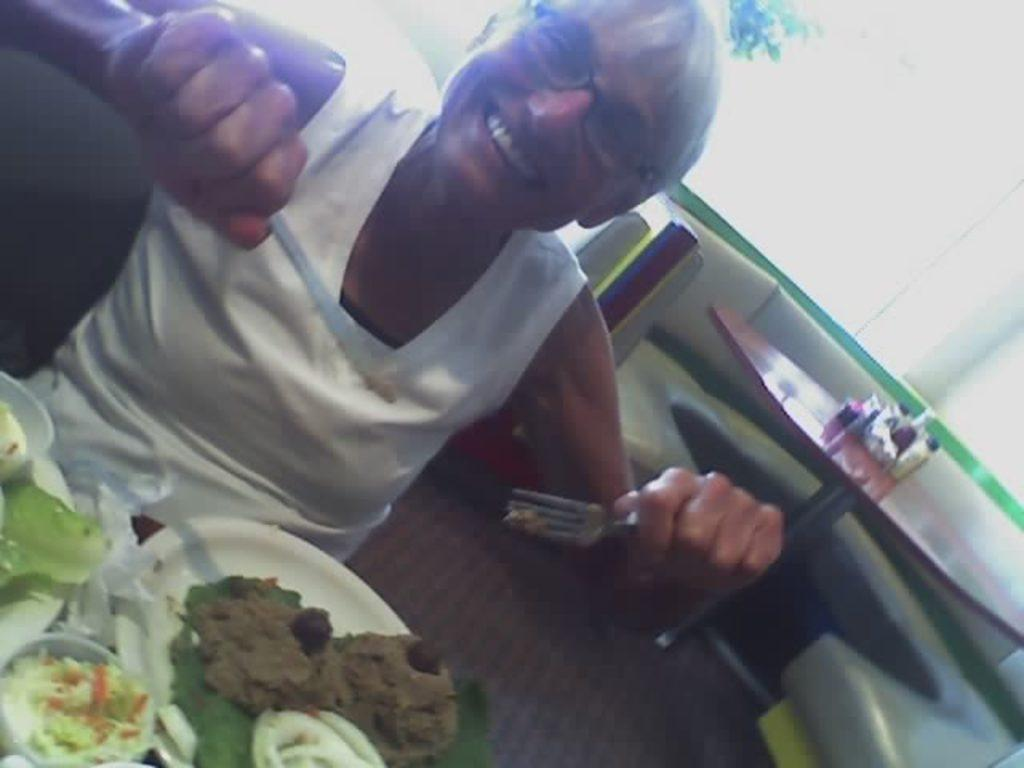What is the person in the image doing? The person is sitting in the image. What is the person holding in their left hand? The person is holding a fork in their left hand. What is the person holding in their right hand? The person is holding a knife in their right hand. What can be found on the table in the image? There are food items on the table. What type of partner is sitting next to the person in the image? There is no mention of a partner in the image. --- Facts: 1. There is a person sitting in the image. 2. The person is wearing a blue shirt. 3. The person is holding a book in their right hand. 4. The book is titled "The History of...". 5. The background of the image is a park. Absurd Topics: elephant, piano, ocean Conversation: What is the main subject in the image? The main subject in the image is a person sitting. What is the person wearing in the image? The person is wearing a blue shirt. What is the person holding in their right hand in the image? The person is holding a book in their right hand. What is the title of the book the person is holding in the image? The book is titled "The History of...". What can be seen in the background of the image? The background of the image is a park. Reasoning: Let's think step by step in order to produce the conversation. We start by identifying the main subject in the image, which is a person sitting. Next, we describe the person's clothing, which is a blue shirt. Then, we observe the action of the person, noting that they are holding a book in their right hand. We then acknowledge the presence of the book's title, which is "The History of...". Finally, we describe the background of the image, which is a park. Absurd Question/Answer: Can you hear the elephant playing the piano by the ocean in the image? There is no mention of an elephant, a piano, or an ocean in the image. 